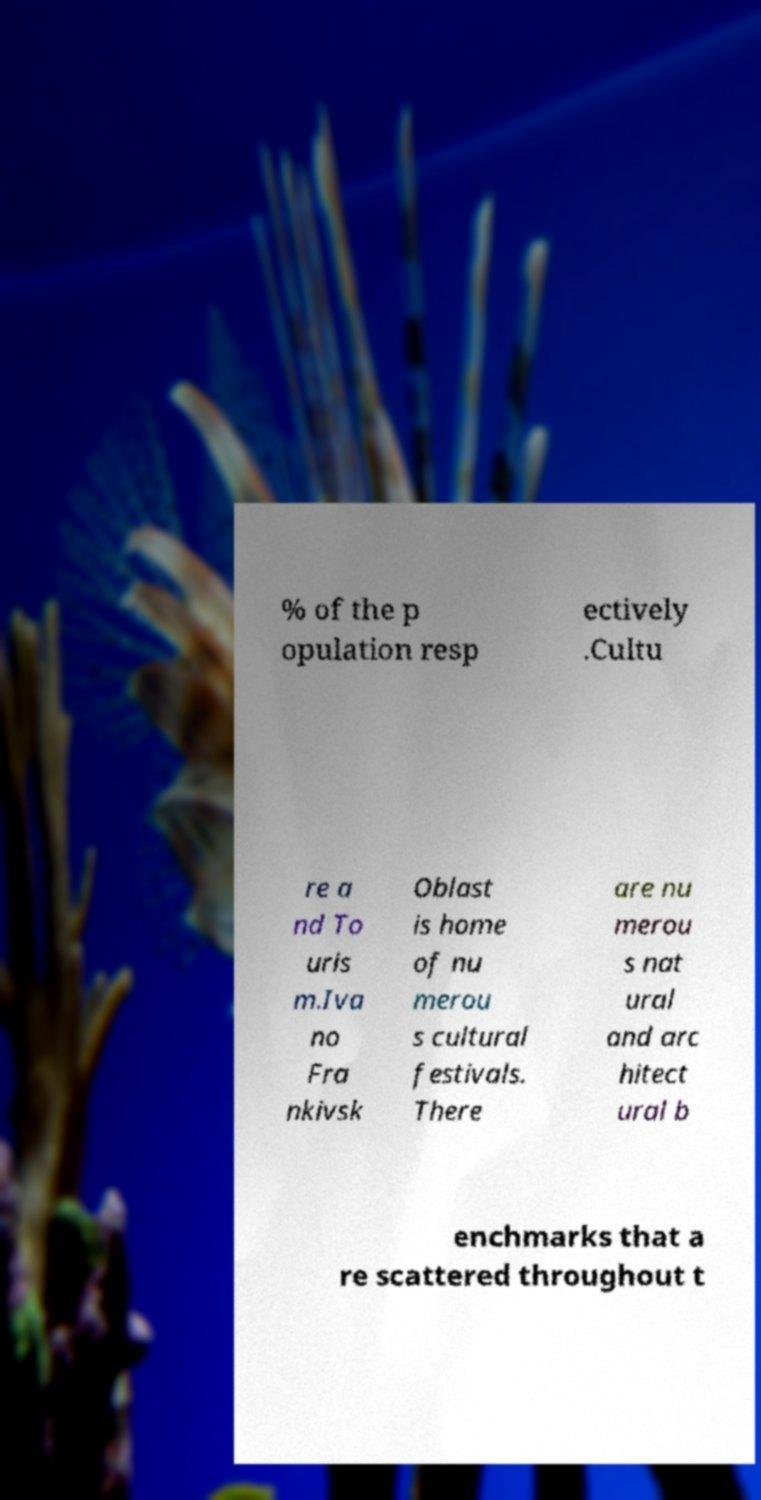For documentation purposes, I need the text within this image transcribed. Could you provide that? % of the p opulation resp ectively .Cultu re a nd To uris m.Iva no Fra nkivsk Oblast is home of nu merou s cultural festivals. There are nu merou s nat ural and arc hitect ural b enchmarks that a re scattered throughout t 